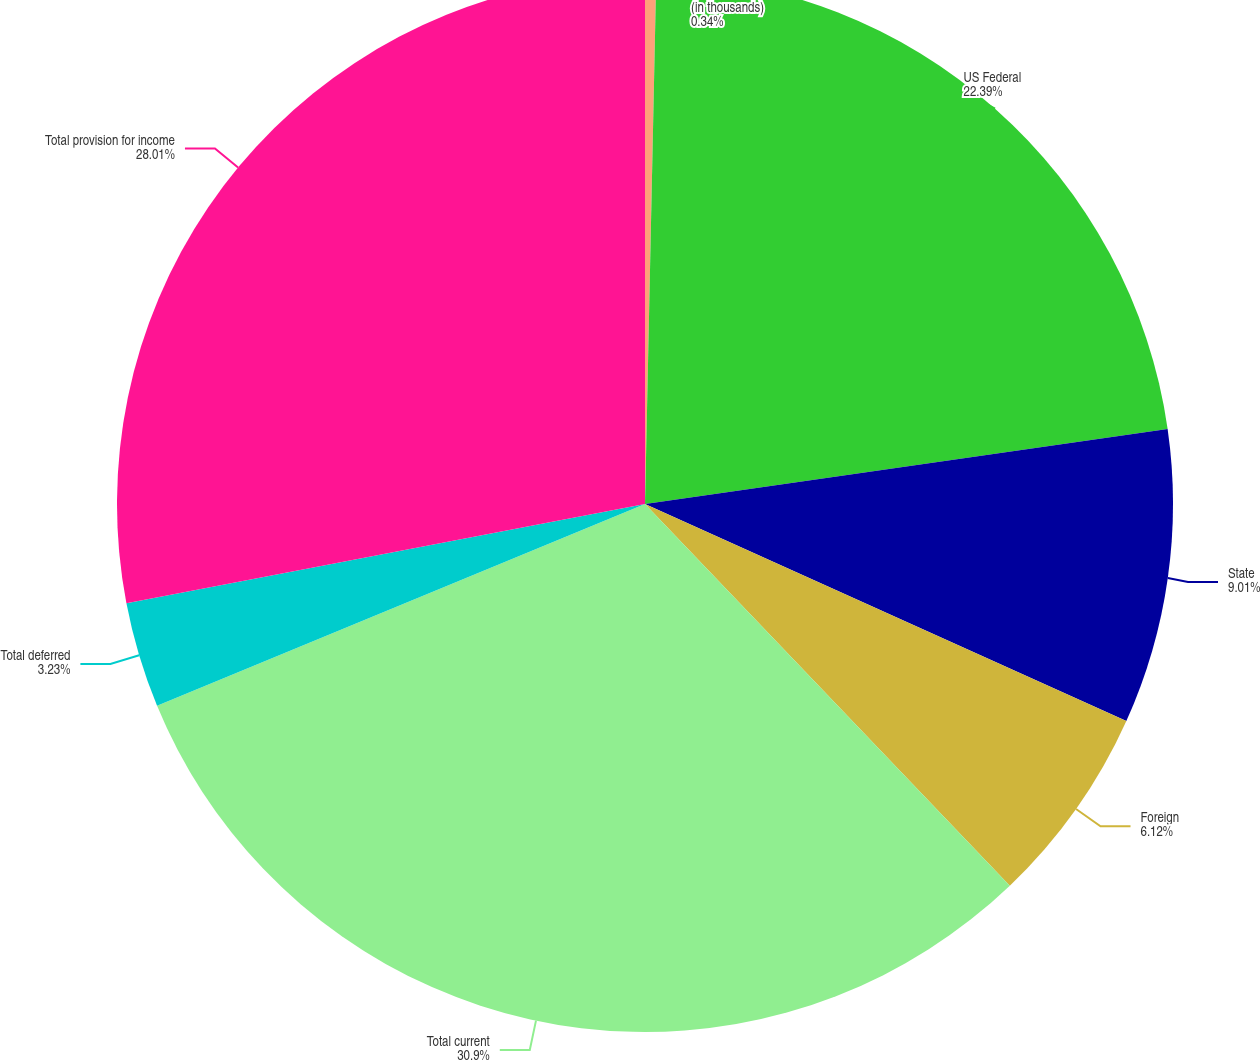<chart> <loc_0><loc_0><loc_500><loc_500><pie_chart><fcel>(in thousands)<fcel>US Federal<fcel>State<fcel>Foreign<fcel>Total current<fcel>Total deferred<fcel>Total provision for income<nl><fcel>0.34%<fcel>22.39%<fcel>9.01%<fcel>6.12%<fcel>30.9%<fcel>3.23%<fcel>28.01%<nl></chart> 